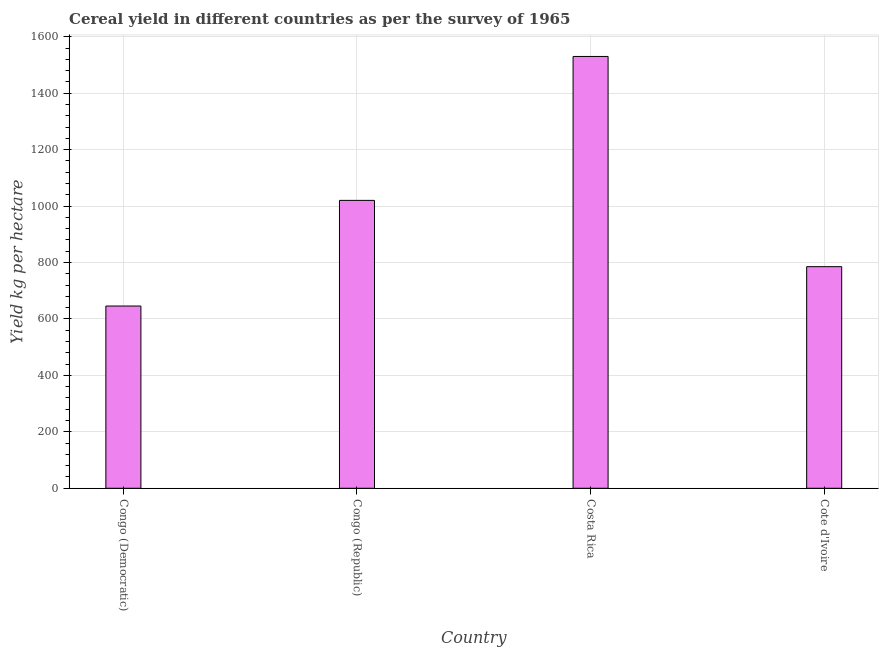Does the graph contain any zero values?
Your answer should be compact. No. Does the graph contain grids?
Offer a terse response. Yes. What is the title of the graph?
Your response must be concise. Cereal yield in different countries as per the survey of 1965. What is the label or title of the Y-axis?
Ensure brevity in your answer.  Yield kg per hectare. What is the cereal yield in Congo (Democratic)?
Ensure brevity in your answer.  645.96. Across all countries, what is the maximum cereal yield?
Keep it short and to the point. 1530.46. Across all countries, what is the minimum cereal yield?
Your answer should be compact. 645.96. In which country was the cereal yield minimum?
Your answer should be very brief. Congo (Democratic). What is the sum of the cereal yield?
Make the answer very short. 3982.3. What is the difference between the cereal yield in Congo (Republic) and Cote d'Ivoire?
Give a very brief answer. 234.93. What is the average cereal yield per country?
Give a very brief answer. 995.58. What is the median cereal yield?
Your response must be concise. 902.94. What is the ratio of the cereal yield in Costa Rica to that in Cote d'Ivoire?
Your answer should be compact. 1.95. Is the cereal yield in Congo (Democratic) less than that in Congo (Republic)?
Provide a short and direct response. Yes. What is the difference between the highest and the second highest cereal yield?
Give a very brief answer. 510.05. What is the difference between the highest and the lowest cereal yield?
Your response must be concise. 884.5. In how many countries, is the cereal yield greater than the average cereal yield taken over all countries?
Your answer should be very brief. 2. What is the difference between two consecutive major ticks on the Y-axis?
Your answer should be very brief. 200. Are the values on the major ticks of Y-axis written in scientific E-notation?
Your answer should be compact. No. What is the Yield kg per hectare of Congo (Democratic)?
Provide a short and direct response. 645.96. What is the Yield kg per hectare of Congo (Republic)?
Provide a short and direct response. 1020.41. What is the Yield kg per hectare in Costa Rica?
Make the answer very short. 1530.46. What is the Yield kg per hectare in Cote d'Ivoire?
Provide a short and direct response. 785.48. What is the difference between the Yield kg per hectare in Congo (Democratic) and Congo (Republic)?
Give a very brief answer. -374.45. What is the difference between the Yield kg per hectare in Congo (Democratic) and Costa Rica?
Your response must be concise. -884.5. What is the difference between the Yield kg per hectare in Congo (Democratic) and Cote d'Ivoire?
Ensure brevity in your answer.  -139.53. What is the difference between the Yield kg per hectare in Congo (Republic) and Costa Rica?
Your answer should be very brief. -510.05. What is the difference between the Yield kg per hectare in Congo (Republic) and Cote d'Ivoire?
Provide a succinct answer. 234.93. What is the difference between the Yield kg per hectare in Costa Rica and Cote d'Ivoire?
Ensure brevity in your answer.  744.98. What is the ratio of the Yield kg per hectare in Congo (Democratic) to that in Congo (Republic)?
Ensure brevity in your answer.  0.63. What is the ratio of the Yield kg per hectare in Congo (Democratic) to that in Costa Rica?
Make the answer very short. 0.42. What is the ratio of the Yield kg per hectare in Congo (Democratic) to that in Cote d'Ivoire?
Provide a short and direct response. 0.82. What is the ratio of the Yield kg per hectare in Congo (Republic) to that in Costa Rica?
Your answer should be compact. 0.67. What is the ratio of the Yield kg per hectare in Congo (Republic) to that in Cote d'Ivoire?
Offer a terse response. 1.3. What is the ratio of the Yield kg per hectare in Costa Rica to that in Cote d'Ivoire?
Keep it short and to the point. 1.95. 